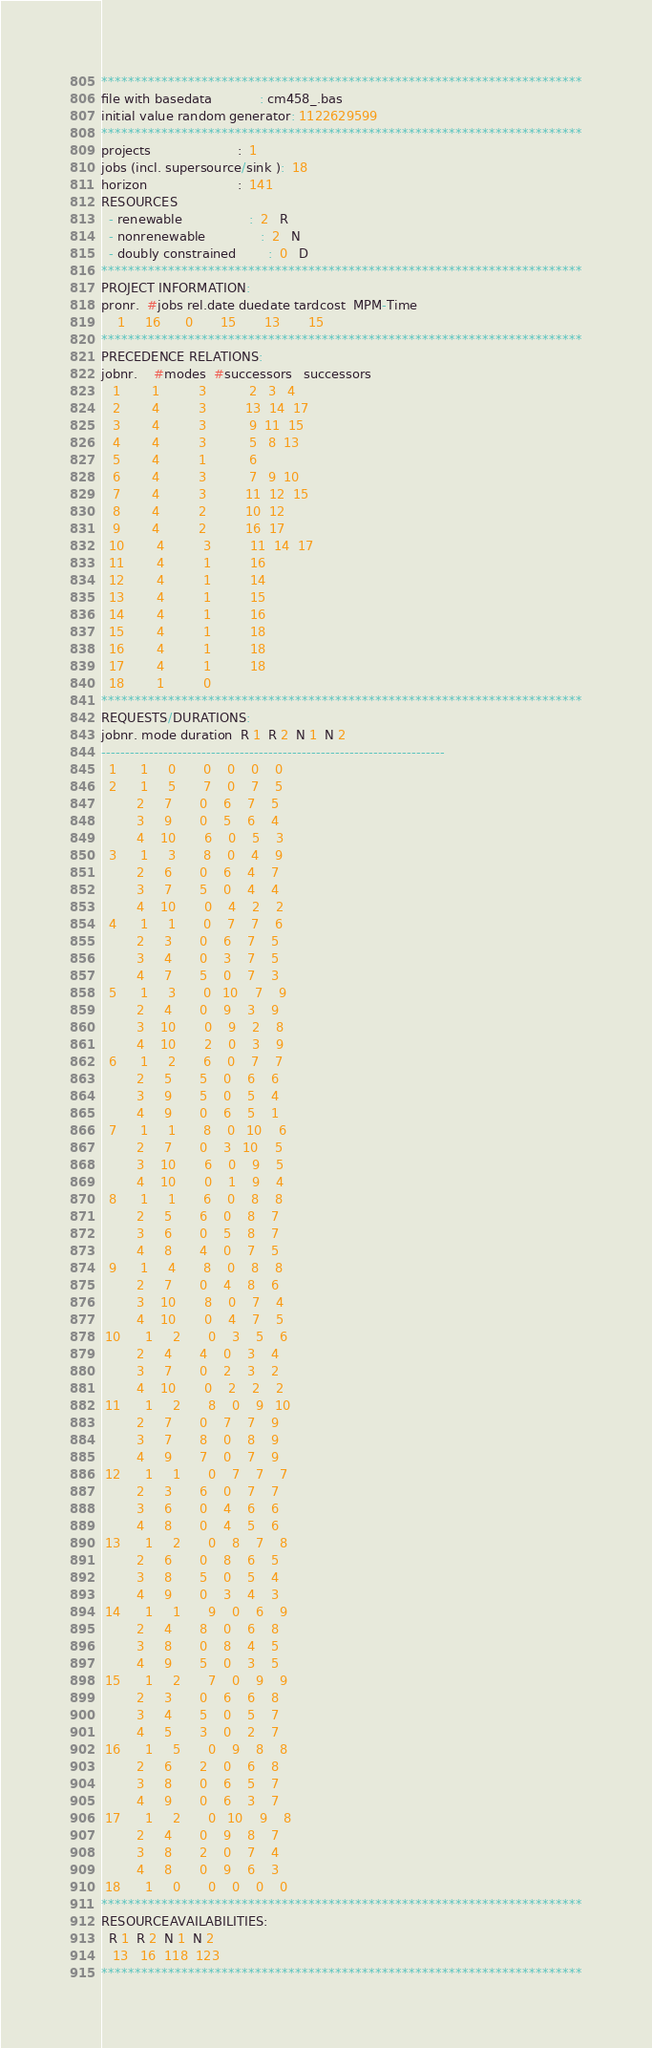<code> <loc_0><loc_0><loc_500><loc_500><_ObjectiveC_>************************************************************************
file with basedata            : cm458_.bas
initial value random generator: 1122629599
************************************************************************
projects                      :  1
jobs (incl. supersource/sink ):  18
horizon                       :  141
RESOURCES
  - renewable                 :  2   R
  - nonrenewable              :  2   N
  - doubly constrained        :  0   D
************************************************************************
PROJECT INFORMATION:
pronr.  #jobs rel.date duedate tardcost  MPM-Time
    1     16      0       15       13       15
************************************************************************
PRECEDENCE RELATIONS:
jobnr.    #modes  #successors   successors
   1        1          3           2   3   4
   2        4          3          13  14  17
   3        4          3           9  11  15
   4        4          3           5   8  13
   5        4          1           6
   6        4          3           7   9  10
   7        4          3          11  12  15
   8        4          2          10  12
   9        4          2          16  17
  10        4          3          11  14  17
  11        4          1          16
  12        4          1          14
  13        4          1          15
  14        4          1          16
  15        4          1          18
  16        4          1          18
  17        4          1          18
  18        1          0        
************************************************************************
REQUESTS/DURATIONS:
jobnr. mode duration  R 1  R 2  N 1  N 2
------------------------------------------------------------------------
  1      1     0       0    0    0    0
  2      1     5       7    0    7    5
         2     7       0    6    7    5
         3     9       0    5    6    4
         4    10       6    0    5    3
  3      1     3       8    0    4    9
         2     6       0    6    4    7
         3     7       5    0    4    4
         4    10       0    4    2    2
  4      1     1       0    7    7    6
         2     3       0    6    7    5
         3     4       0    3    7    5
         4     7       5    0    7    3
  5      1     3       0   10    7    9
         2     4       0    9    3    9
         3    10       0    9    2    8
         4    10       2    0    3    9
  6      1     2       6    0    7    7
         2     5       5    0    6    6
         3     9       5    0    5    4
         4     9       0    6    5    1
  7      1     1       8    0   10    6
         2     7       0    3   10    5
         3    10       6    0    9    5
         4    10       0    1    9    4
  8      1     1       6    0    8    8
         2     5       6    0    8    7
         3     6       0    5    8    7
         4     8       4    0    7    5
  9      1     4       8    0    8    8
         2     7       0    4    8    6
         3    10       8    0    7    4
         4    10       0    4    7    5
 10      1     2       0    3    5    6
         2     4       4    0    3    4
         3     7       0    2    3    2
         4    10       0    2    2    2
 11      1     2       8    0    9   10
         2     7       0    7    7    9
         3     7       8    0    8    9
         4     9       7    0    7    9
 12      1     1       0    7    7    7
         2     3       6    0    7    7
         3     6       0    4    6    6
         4     8       0    4    5    6
 13      1     2       0    8    7    8
         2     6       0    8    6    5
         3     8       5    0    5    4
         4     9       0    3    4    3
 14      1     1       9    0    6    9
         2     4       8    0    6    8
         3     8       0    8    4    5
         4     9       5    0    3    5
 15      1     2       7    0    9    9
         2     3       0    6    6    8
         3     4       5    0    5    7
         4     5       3    0    2    7
 16      1     5       0    9    8    8
         2     6       2    0    6    8
         3     8       0    6    5    7
         4     9       0    6    3    7
 17      1     2       0   10    9    8
         2     4       0    9    8    7
         3     8       2    0    7    4
         4     8       0    9    6    3
 18      1     0       0    0    0    0
************************************************************************
RESOURCEAVAILABILITIES:
  R 1  R 2  N 1  N 2
   13   16  118  123
************************************************************************
</code> 